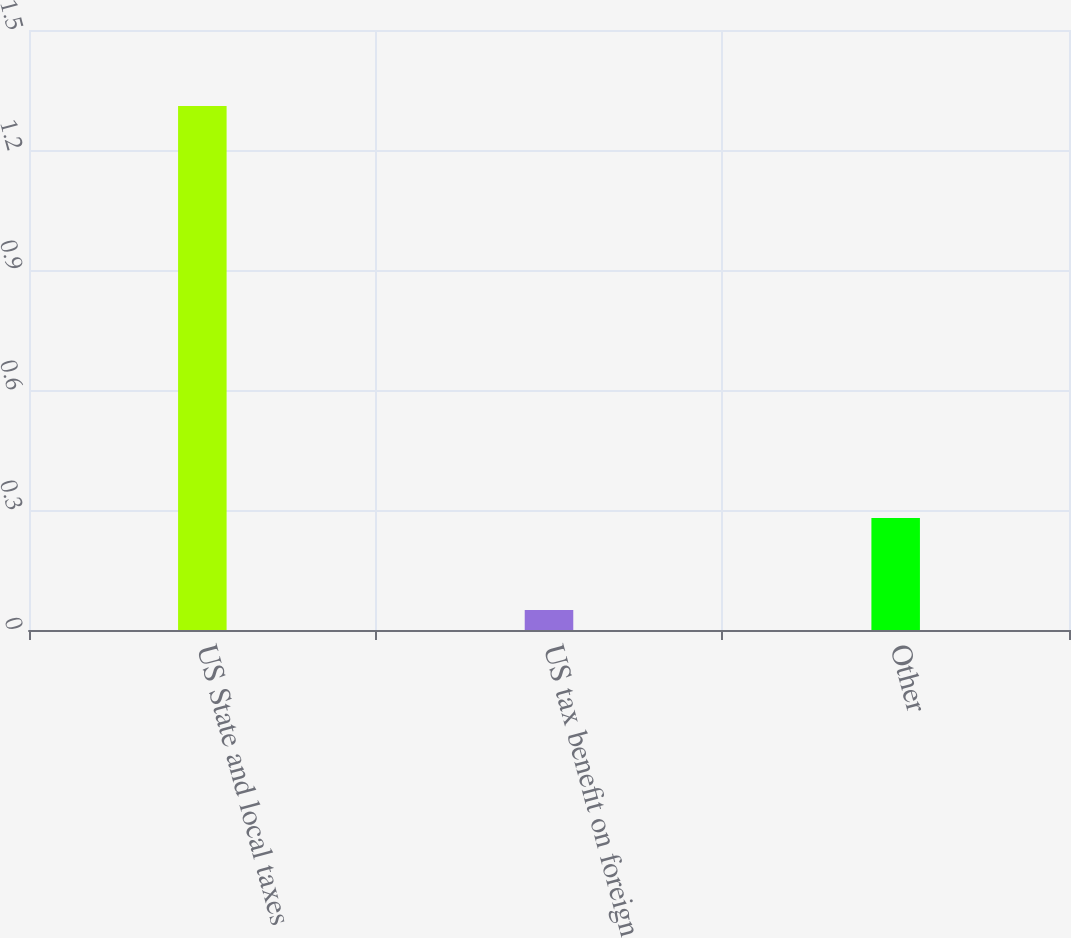Convert chart to OTSL. <chart><loc_0><loc_0><loc_500><loc_500><bar_chart><fcel>US State and local taxes<fcel>US tax benefit on foreign<fcel>Other<nl><fcel>1.31<fcel>0.05<fcel>0.28<nl></chart> 